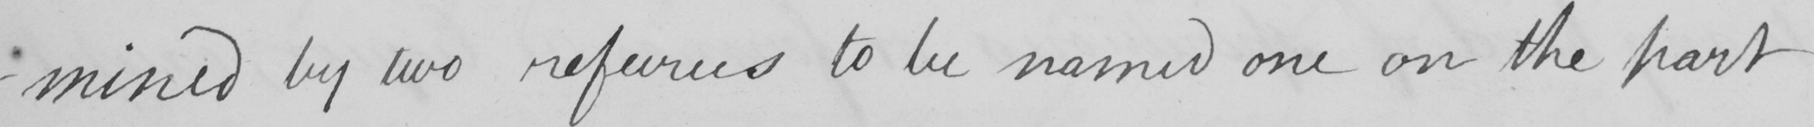Can you tell me what this handwritten text says? -mined by two refeurees to be named one on the part 